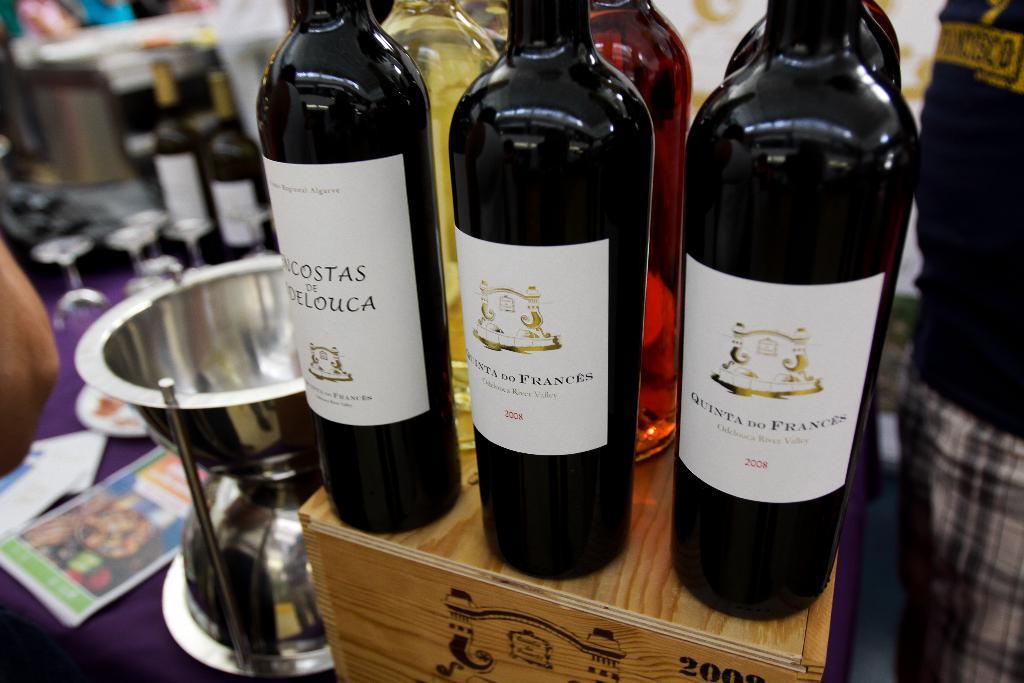Could you give a brief overview of what you see in this image? In this picture we can see wine bottles on the wooden box. On the table we can see wine bottles, glasses, papers, bowls and other objects. 